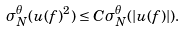Convert formula to latex. <formula><loc_0><loc_0><loc_500><loc_500>\sigma _ { N } ^ { \theta } ( u ( f ) ^ { 2 } ) \leq C \sigma _ { N } ^ { \theta } ( | u ( f ) | ) .</formula> 